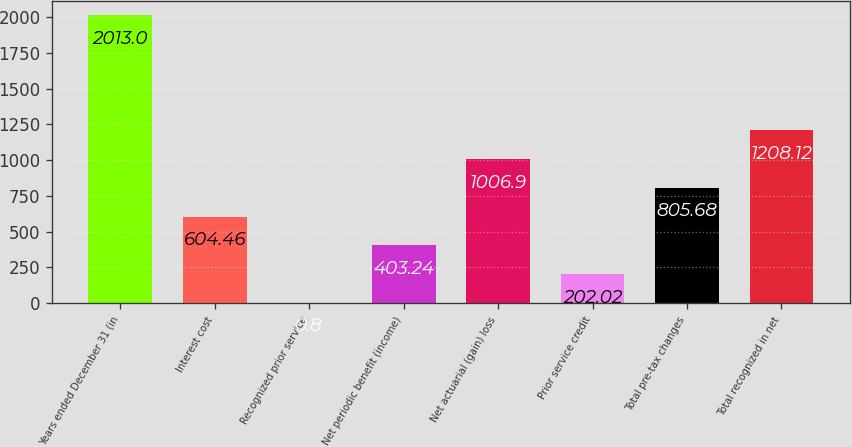Convert chart. <chart><loc_0><loc_0><loc_500><loc_500><bar_chart><fcel>Years ended December 31 (in<fcel>Interest cost<fcel>Recognized prior service<fcel>Net periodic benefit (income)<fcel>Net actuarial (gain) loss<fcel>Prior service credit<fcel>Total pre-tax changes<fcel>Total recognized in net<nl><fcel>2013<fcel>604.46<fcel>0.8<fcel>403.24<fcel>1006.9<fcel>202.02<fcel>805.68<fcel>1208.12<nl></chart> 